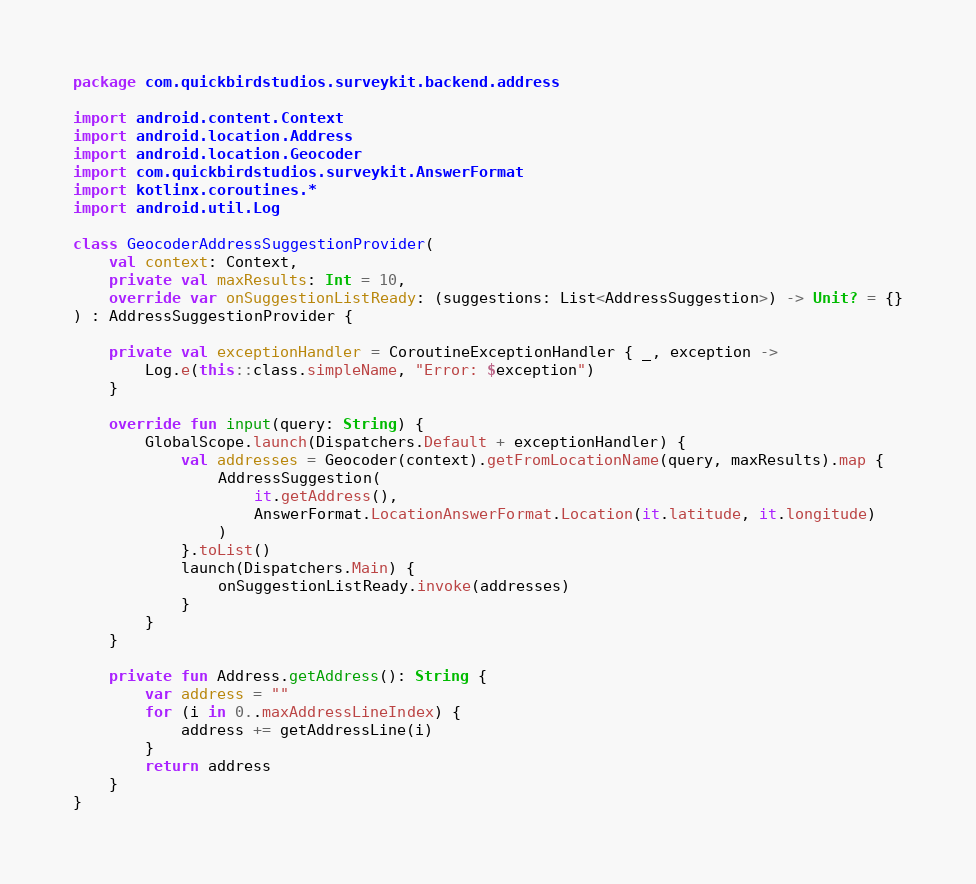<code> <loc_0><loc_0><loc_500><loc_500><_Kotlin_>package com.quickbirdstudios.surveykit.backend.address

import android.content.Context
import android.location.Address
import android.location.Geocoder
import com.quickbirdstudios.surveykit.AnswerFormat
import kotlinx.coroutines.*
import android.util.Log

class GeocoderAddressSuggestionProvider(
    val context: Context,
    private val maxResults: Int = 10,
    override var onSuggestionListReady: (suggestions: List<AddressSuggestion>) -> Unit? = {}
) : AddressSuggestionProvider {

    private val exceptionHandler = CoroutineExceptionHandler { _, exception ->
        Log.e(this::class.simpleName, "Error: $exception")
    }

    override fun input(query: String) {
        GlobalScope.launch(Dispatchers.Default + exceptionHandler) {
            val addresses = Geocoder(context).getFromLocationName(query, maxResults).map {
                AddressSuggestion(
                    it.getAddress(),
                    AnswerFormat.LocationAnswerFormat.Location(it.latitude, it.longitude)
                )
            }.toList()
            launch(Dispatchers.Main) {
                onSuggestionListReady.invoke(addresses)
            }
        }
    }

    private fun Address.getAddress(): String {
        var address = ""
        for (i in 0..maxAddressLineIndex) {
            address += getAddressLine(i)
        }
        return address
    }
}
</code> 